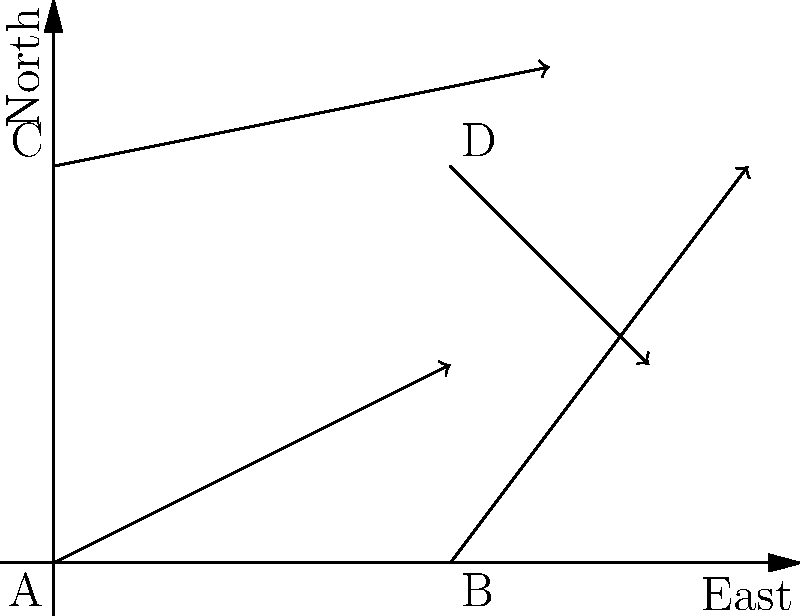On the weather map above, which point has the strongest wind? To determine which point has the strongest wind, we need to compare the length (magnitude) of the arrows at each point. The longer the arrow, the stronger the wind. Let's go through this step-by-step:

1. Look at point A (bottom-left): The arrow is fairly long and points northeast.
2. Look at point B (bottom-right): The arrow is also long and points mostly north with a slight eastward direction.
3. Look at point C (top-left): This arrow is the longest of all four, pointing mostly east with a slight northward direction.
4. Look at point D (top-right): This arrow is the shortest, pointing southeast.

Comparing the lengths visually, we can see that the arrow at point C is the longest. This means the wind is strongest at point C.

Remember, in wind vector maps, the length of the arrow represents the wind speed (magnitude), while the direction of the arrow shows which way the wind is blowing towards.
Answer: C 